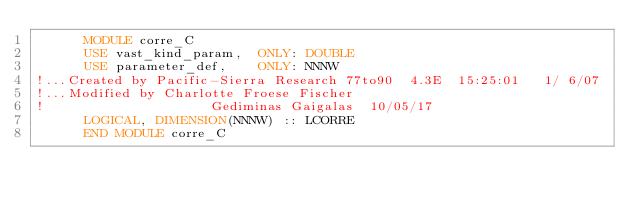Convert code to text. <code><loc_0><loc_0><loc_500><loc_500><_FORTRAN_>      MODULE corre_C
      USE vast_kind_param,  ONLY: DOUBLE
      USE parameter_def,    ONLY: NNNW
!...Created by Pacific-Sierra Research 77to90  4.3E  15:25:01   1/ 6/07
!...Modified by Charlotte Froese Fischer
!                     Gediminas Gaigalas  10/05/17
      LOGICAL, DIMENSION(NNNW) :: LCORRE
      END MODULE corre_C
</code> 